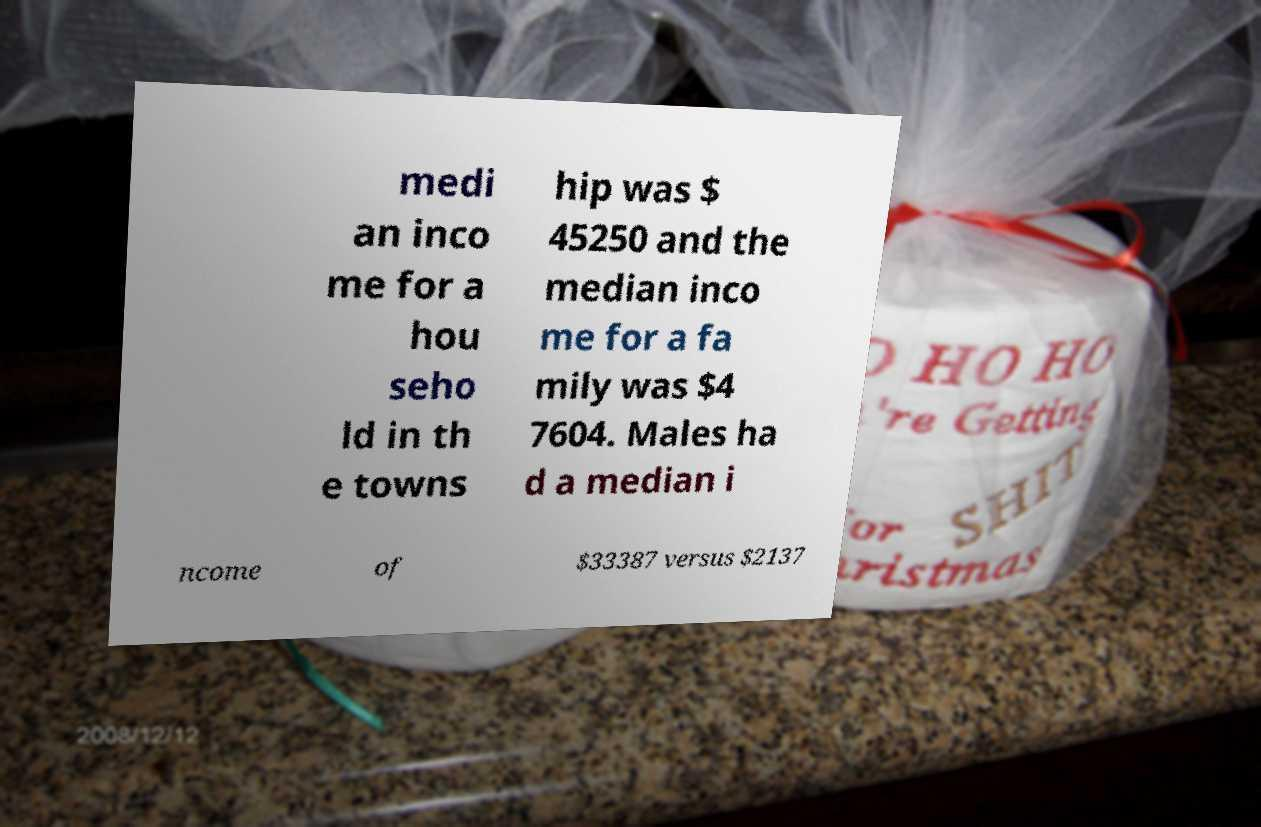Can you accurately transcribe the text from the provided image for me? medi an inco me for a hou seho ld in th e towns hip was $ 45250 and the median inco me for a fa mily was $4 7604. Males ha d a median i ncome of $33387 versus $2137 